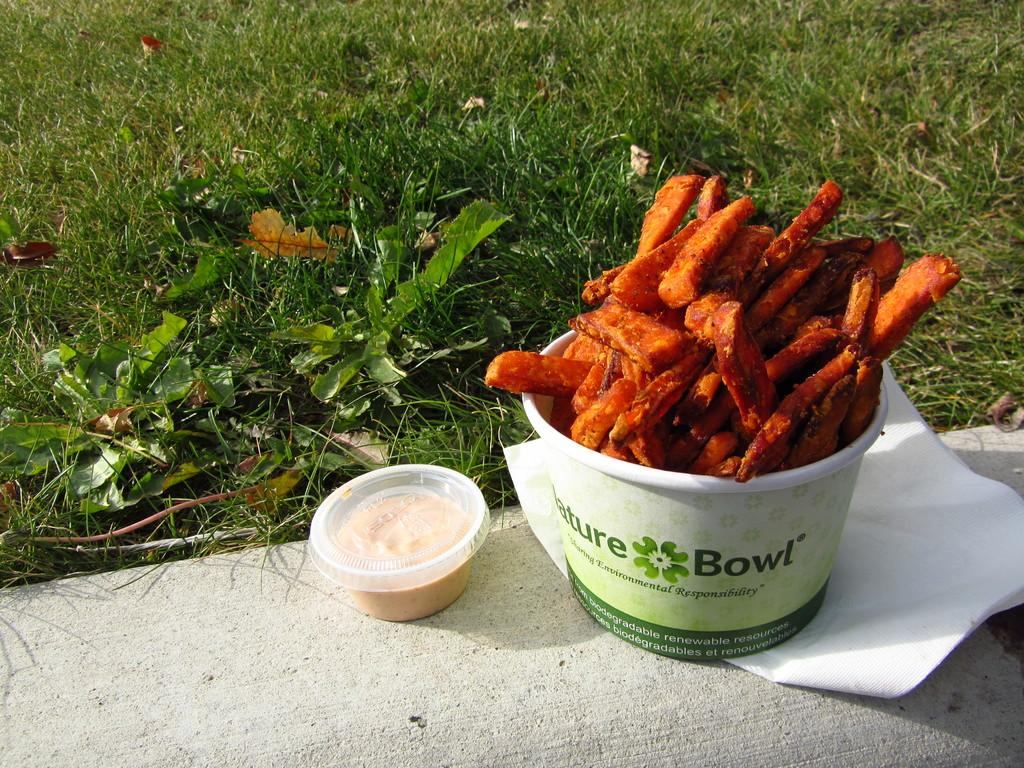What is present in the containers in the image? There are two containers with food in the image. What is the surface on which the containers are placed? The containers are placed on a paper. Where is the paper located? The paper is on the ground. What can be seen in the background of the image? There are plants in the background of the image. What type of company is depicted in the image? There is no company depicted in the image; it features containers with food placed on a paper on the ground, with plants in the background. 